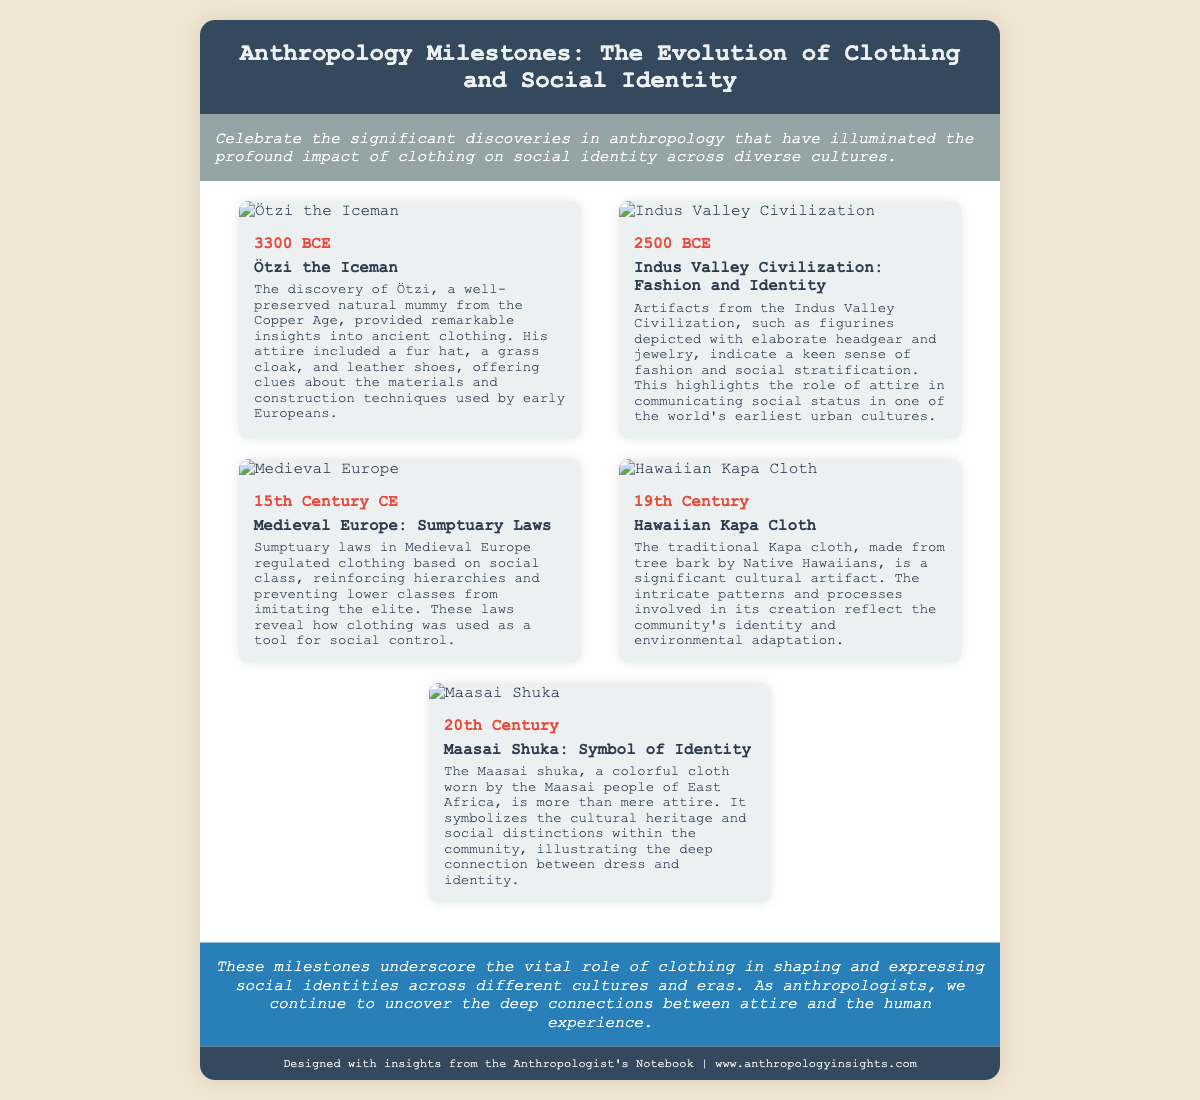What year does the Ötzi the Iceman date back to? The document states that Ötzi the Iceman dates back to 3300 BCE.
Answer: 3300 BCE What is the significance of the Indus Valley artifacts? The artifacts indicate a keen sense of fashion and social stratification in the Indus Valley Civilization.
Answer: Fashion and social stratification What type of cloth is the Maasai shuka? The Maasai shuka is described as a colorful cloth worn by the Maasai people.
Answer: Colorful cloth Which civilization is associated with sumptuary laws? The sumptuary laws are associated with Medieval Europe.
Answer: Medieval Europe In which century was the Hawaiian Kapa cloth significant? The document mentions the Kapa cloth as significant in the 19th century.
Answer: 19th Century What does the term "social identity" relate to in the context of this greeting card? The greeting card discusses how clothing reflects and shapes social identity across cultures.
Answer: Clothing and social identity How many milestones are highlighted in the document? The document lists five significant milestones related to clothing and attire.
Answer: Five What type of clothing did Ötzi the Iceman wear? Ötzi's attire included a fur hat, a grass cloak, and leather shoes.
Answer: Fur hat, grass cloak, leather shoes 